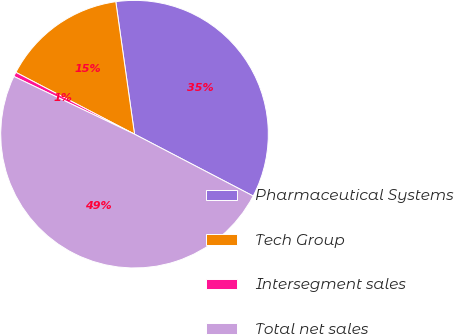<chart> <loc_0><loc_0><loc_500><loc_500><pie_chart><fcel>Pharmaceutical Systems<fcel>Tech Group<fcel>Intersegment sales<fcel>Total net sales<nl><fcel>34.88%<fcel>15.12%<fcel>0.54%<fcel>49.46%<nl></chart> 